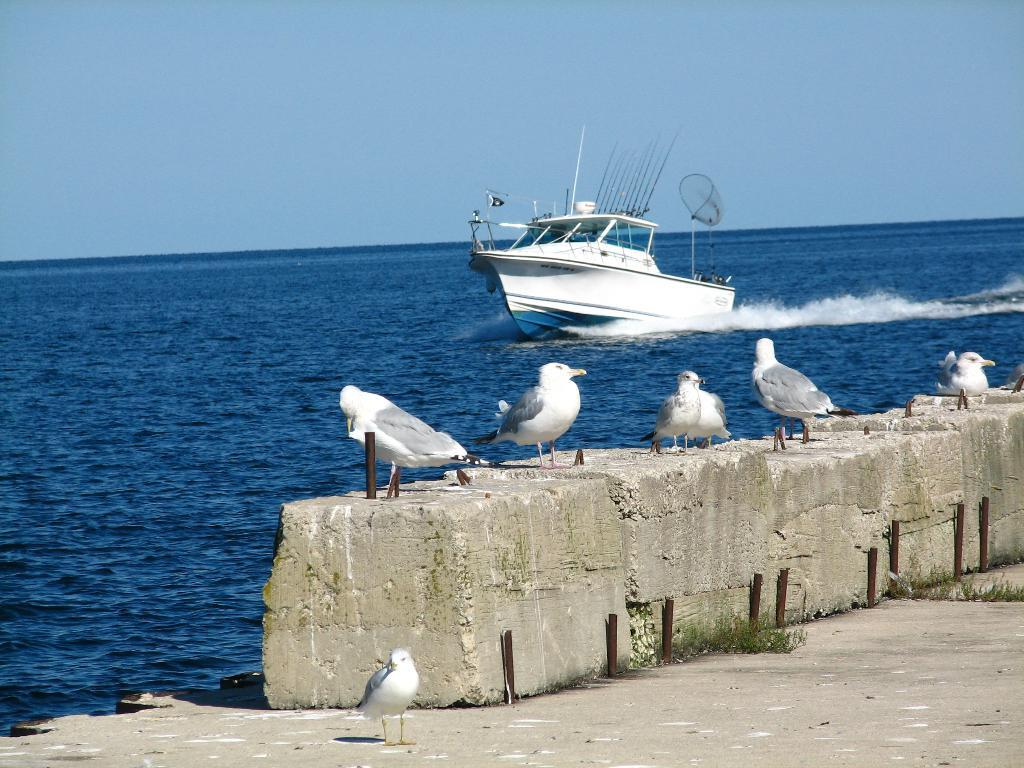What is in the water in the image? There is a boat in the water. What can be seen on the ground in the image? There are birds on the ground. How would you describe the sky in the image? The sky is cloudy. What type of border can be seen between the water and the sky in the image? There is no border visible between the water and the sky in the image. Are there any trains present in the image? No, there are no trains present in the image. 